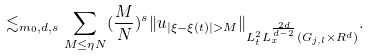<formula> <loc_0><loc_0><loc_500><loc_500>\lesssim _ { m _ { 0 } , d , s } \sum _ { M \leq \eta N } ( \frac { M } { N } ) ^ { s } \| u _ { | \xi - \xi ( t ) | > M } \| _ { L _ { t } ^ { 2 } L _ { x } ^ { \frac { 2 d } { d - 2 } } ( G _ { j , l } \times R ^ { d } ) } .</formula> 